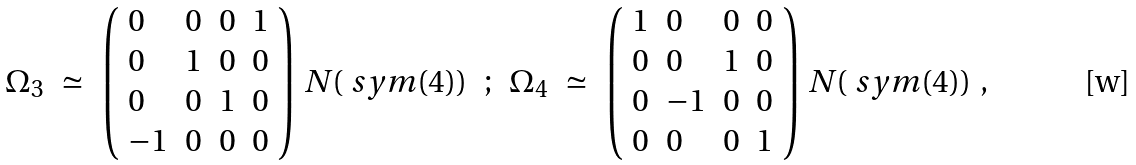Convert formula to latex. <formula><loc_0><loc_0><loc_500><loc_500>\begin{array} { r c l c r c l } \Omega _ { 3 } & \simeq & \left ( \begin{array} { l l l l } 0 & 0 & 0 & 1 \\ 0 & 1 & 0 & 0 \\ 0 & 0 & 1 & 0 \\ - 1 & 0 & 0 & 0 \end{array} \right ) \, N ( \ s y m ( 4 ) ) & ; & \Omega _ { 4 } & \simeq & \left ( \begin{array} { l l l l } 1 & 0 & 0 & 0 \\ 0 & 0 & 1 & 0 \\ 0 & - 1 & 0 & 0 \\ 0 & 0 & 0 & 1 \end{array} \right ) \, N ( \ s y m ( 4 ) ) \\ \end{array} ,</formula> 